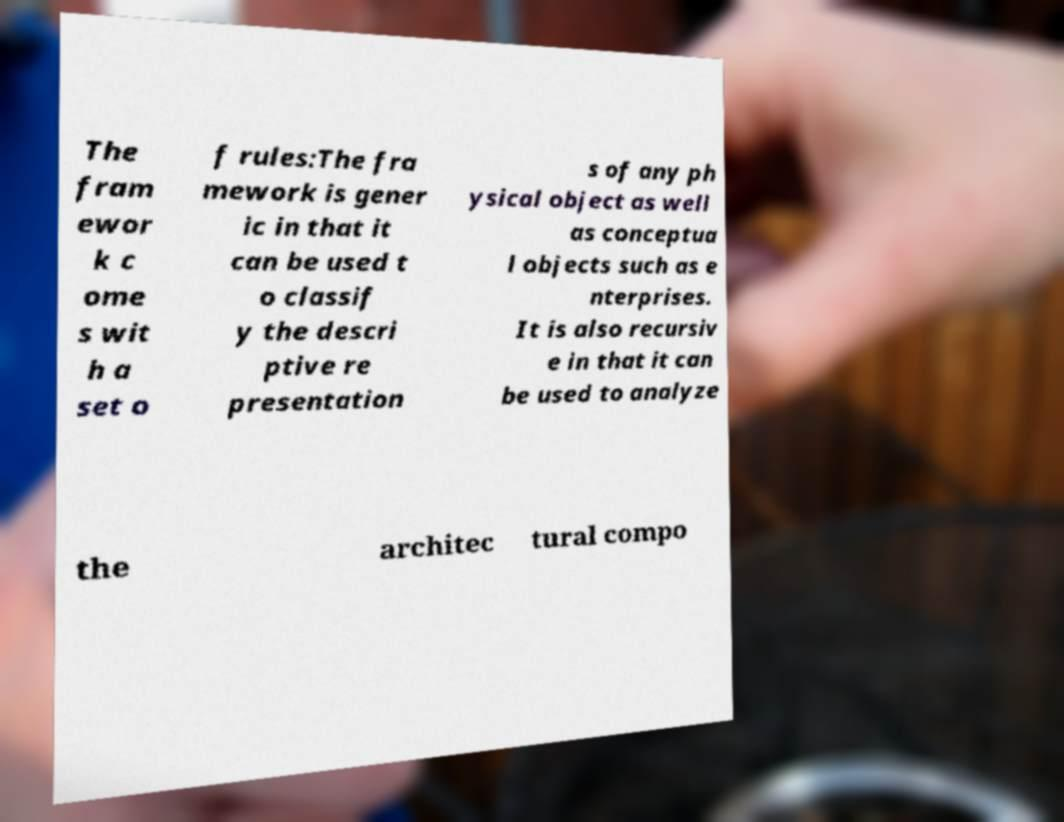What messages or text are displayed in this image? I need them in a readable, typed format. The fram ewor k c ome s wit h a set o f rules:The fra mework is gener ic in that it can be used t o classif y the descri ptive re presentation s of any ph ysical object as well as conceptua l objects such as e nterprises. It is also recursiv e in that it can be used to analyze the architec tural compo 